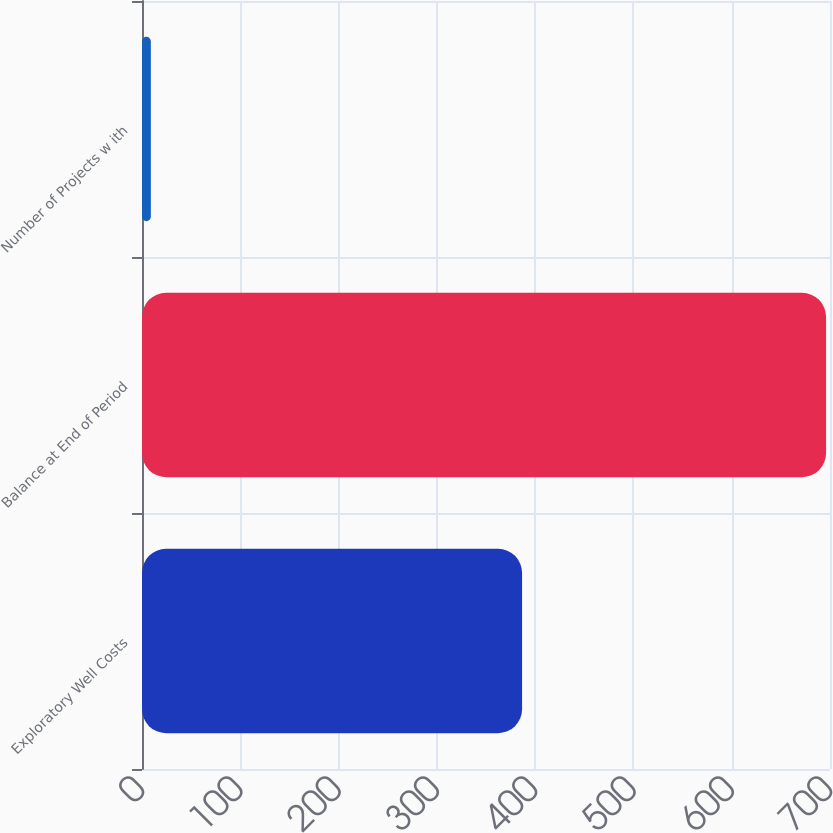Convert chart. <chart><loc_0><loc_0><loc_500><loc_500><bar_chart><fcel>Exploratory Well Costs<fcel>Balance at End of Period<fcel>Number of Projects w ith<nl><fcel>386.7<fcel>696<fcel>9<nl></chart> 